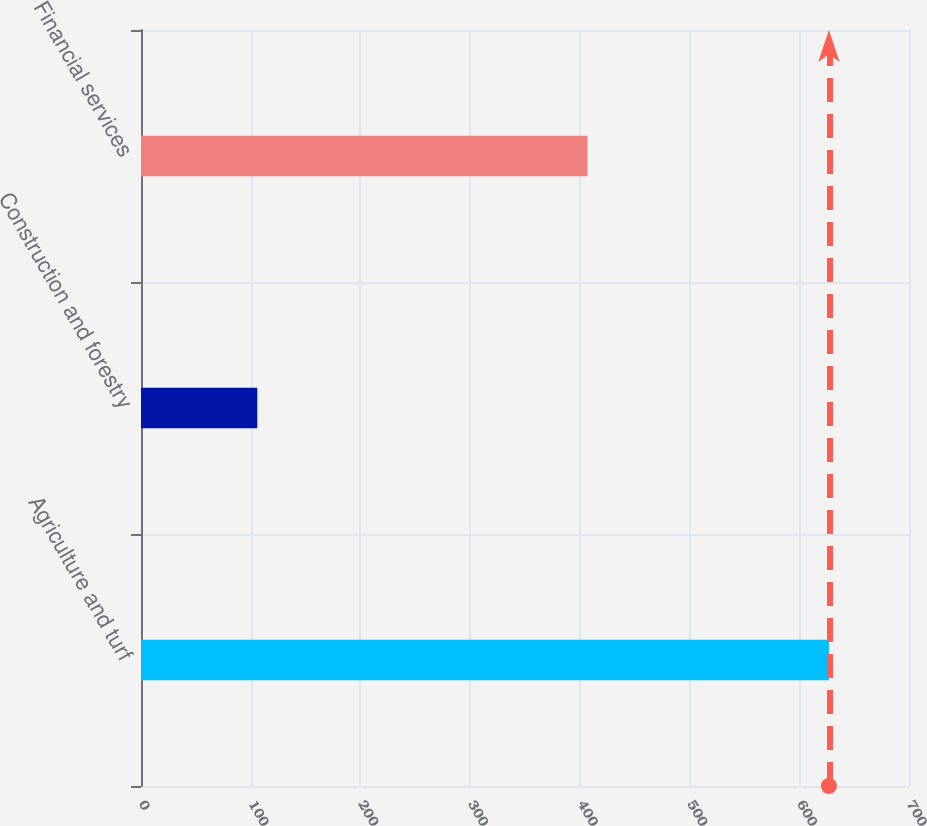<chart> <loc_0><loc_0><loc_500><loc_500><bar_chart><fcel>Agriculture and turf<fcel>Construction and forestry<fcel>Financial services<nl><fcel>627<fcel>106<fcel>407<nl></chart> 